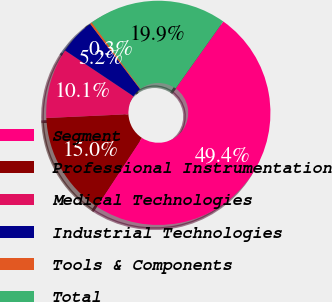Convert chart. <chart><loc_0><loc_0><loc_500><loc_500><pie_chart><fcel>Segment<fcel>Professional Instrumentation<fcel>Medical Technologies<fcel>Industrial Technologies<fcel>Tools & Components<fcel>Total<nl><fcel>49.41%<fcel>15.03%<fcel>10.12%<fcel>5.21%<fcel>0.3%<fcel>19.94%<nl></chart> 